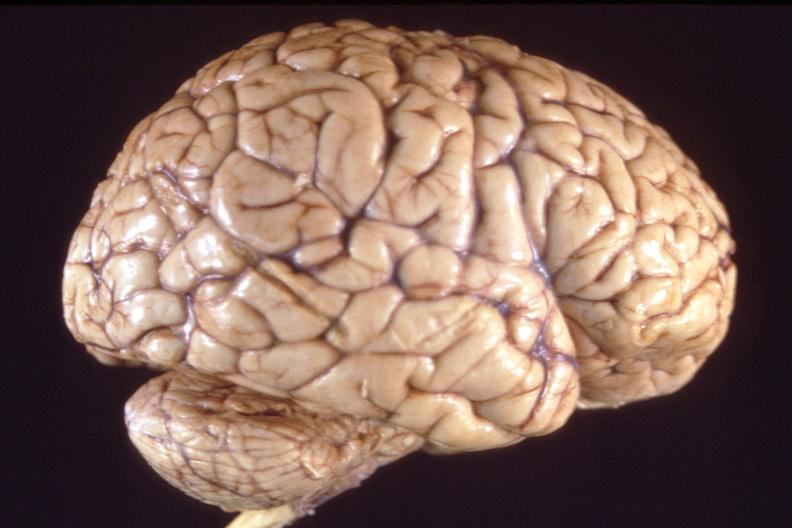s supernumerary digits present?
Answer the question using a single word or phrase. No 